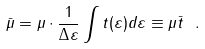<formula> <loc_0><loc_0><loc_500><loc_500>\bar { \mu } = \mu \cdot \frac { 1 } { \Delta \varepsilon } \int t ( \varepsilon ) d \varepsilon \equiv \mu \bar { t } \ .</formula> 